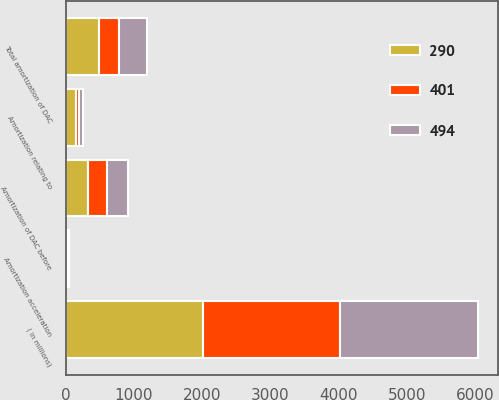Convert chart. <chart><loc_0><loc_0><loc_500><loc_500><stacked_bar_chart><ecel><fcel>( in millions)<fcel>Amortization of DAC before<fcel>Amortization relating to<fcel>Amortization acceleration<fcel>Total amortization of DAC<nl><fcel>494<fcel>2012<fcel>310<fcel>57<fcel>34<fcel>401<nl><fcel>290<fcel>2011<fcel>331<fcel>156<fcel>7<fcel>494<nl><fcel>401<fcel>2010<fcel>270<fcel>36<fcel>16<fcel>290<nl></chart> 